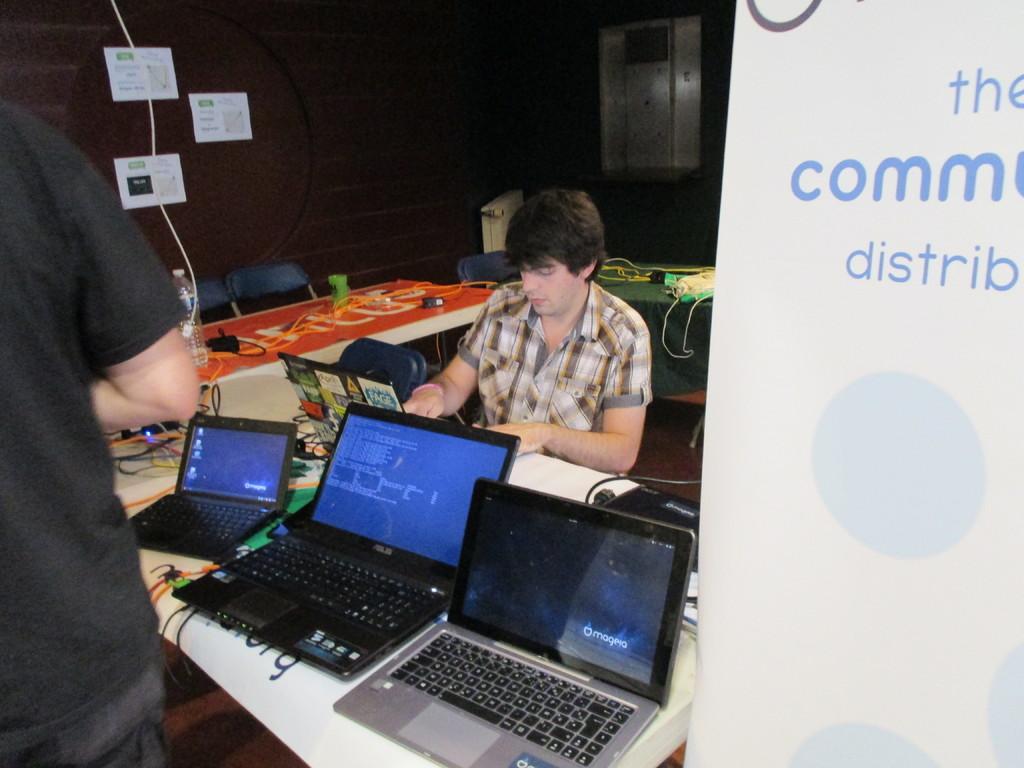What is on the poster to the right?
Provide a short and direct response. The comm distrib. What is the brand of the laptop in the middle?
Offer a terse response. Asus. 